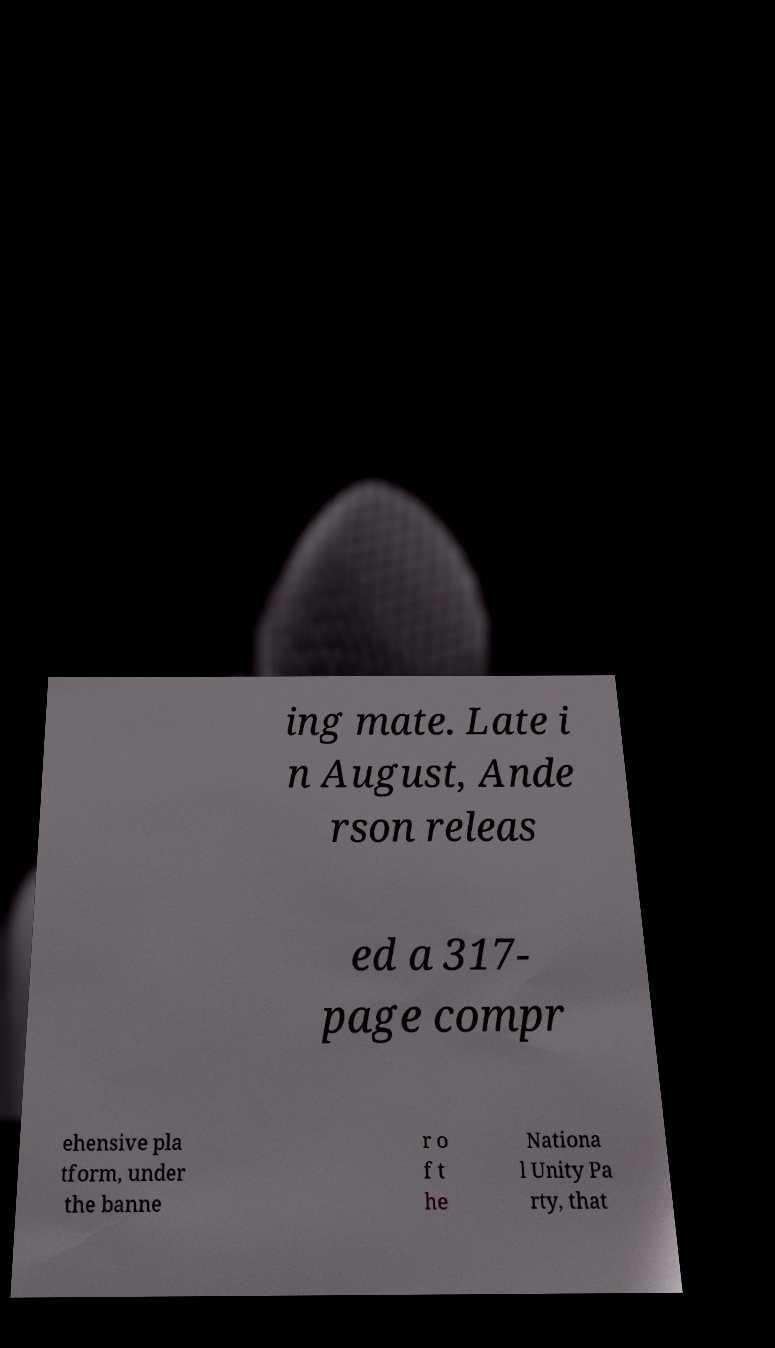For documentation purposes, I need the text within this image transcribed. Could you provide that? ing mate. Late i n August, Ande rson releas ed a 317- page compr ehensive pla tform, under the banne r o f t he Nationa l Unity Pa rty, that 